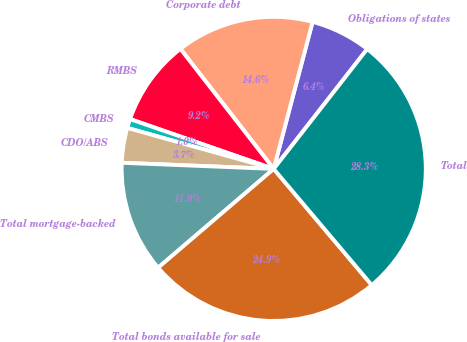Convert chart. <chart><loc_0><loc_0><loc_500><loc_500><pie_chart><fcel>Obligations of states<fcel>Corporate debt<fcel>RMBS<fcel>CMBS<fcel>CDO/ABS<fcel>Total mortgage-backed<fcel>Total bonds available for sale<fcel>Total<nl><fcel>6.43%<fcel>14.63%<fcel>9.17%<fcel>0.97%<fcel>3.7%<fcel>11.9%<fcel>24.9%<fcel>28.3%<nl></chart> 